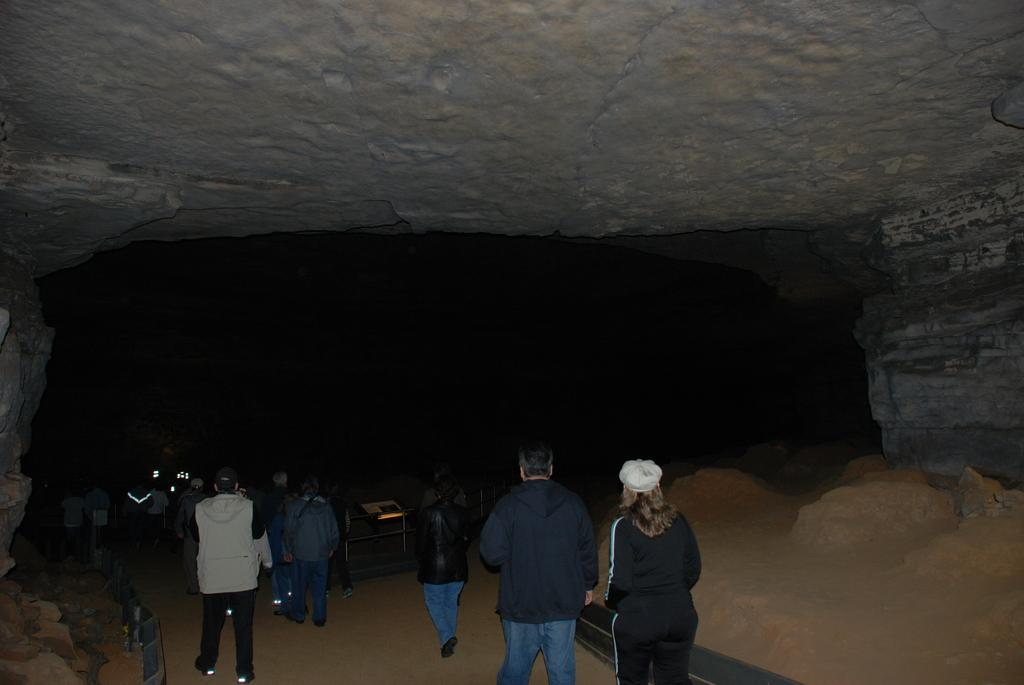What is located at the bottom of the image? At the bottom of the image, there are persons, barricades, boards, and rocks. What can be seen in the background of the image? There is a cave visible in the background of the image. What type of science experiment is being conducted with the wrench and crown in the image? There is no wrench or crown present in the image, so no such experiment can be observed. 